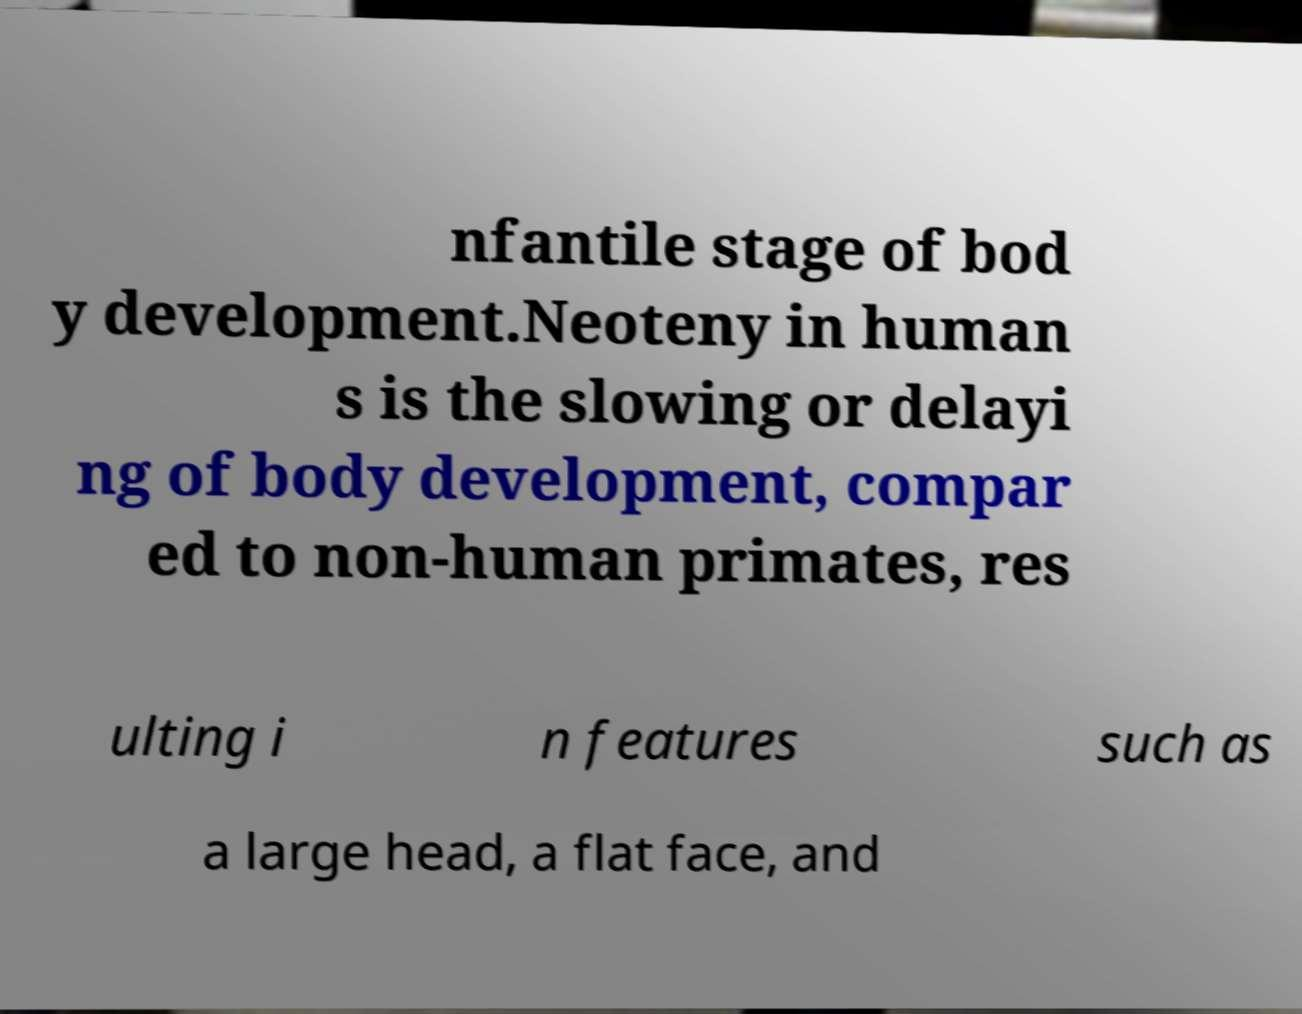For documentation purposes, I need the text within this image transcribed. Could you provide that? nfantile stage of bod y development.Neoteny in human s is the slowing or delayi ng of body development, compar ed to non-human primates, res ulting i n features such as a large head, a flat face, and 